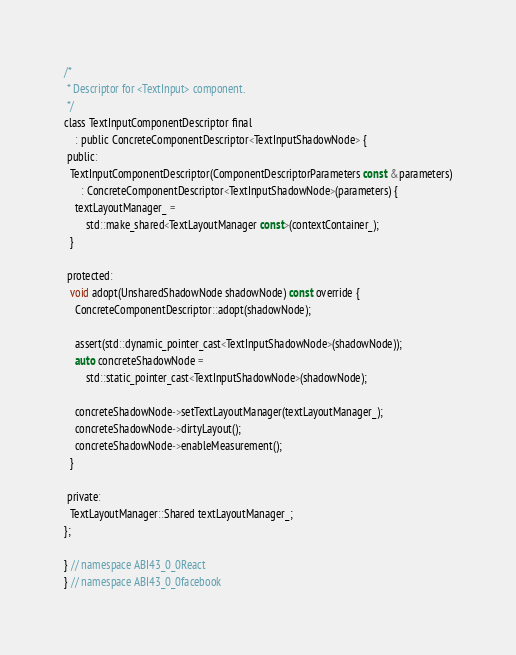Convert code to text. <code><loc_0><loc_0><loc_500><loc_500><_C_>
/*
 * Descriptor for <TextInput> component.
 */
class TextInputComponentDescriptor final
    : public ConcreteComponentDescriptor<TextInputShadowNode> {
 public:
  TextInputComponentDescriptor(ComponentDescriptorParameters const &parameters)
      : ConcreteComponentDescriptor<TextInputShadowNode>(parameters) {
    textLayoutManager_ =
        std::make_shared<TextLayoutManager const>(contextContainer_);
  }

 protected:
  void adopt(UnsharedShadowNode shadowNode) const override {
    ConcreteComponentDescriptor::adopt(shadowNode);

    assert(std::dynamic_pointer_cast<TextInputShadowNode>(shadowNode));
    auto concreteShadowNode =
        std::static_pointer_cast<TextInputShadowNode>(shadowNode);

    concreteShadowNode->setTextLayoutManager(textLayoutManager_);
    concreteShadowNode->dirtyLayout();
    concreteShadowNode->enableMeasurement();
  }

 private:
  TextLayoutManager::Shared textLayoutManager_;
};

} // namespace ABI43_0_0React
} // namespace ABI43_0_0facebook
</code> 